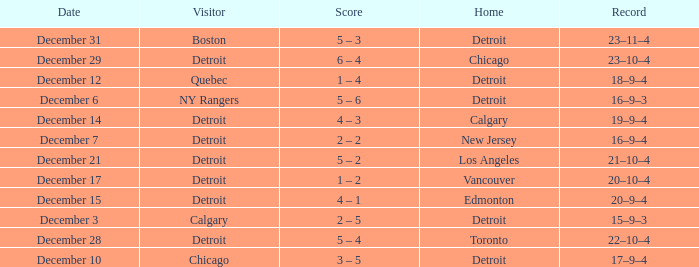Can you identify the person visiting on the 31st of december? Boston. Give me the full table as a dictionary. {'header': ['Date', 'Visitor', 'Score', 'Home', 'Record'], 'rows': [['December 31', 'Boston', '5 – 3', 'Detroit', '23–11–4'], ['December 29', 'Detroit', '6 – 4', 'Chicago', '23–10–4'], ['December 12', 'Quebec', '1 – 4', 'Detroit', '18–9–4'], ['December 6', 'NY Rangers', '5 – 6', 'Detroit', '16–9–3'], ['December 14', 'Detroit', '4 – 3', 'Calgary', '19–9–4'], ['December 7', 'Detroit', '2 – 2', 'New Jersey', '16–9–4'], ['December 21', 'Detroit', '5 – 2', 'Los Angeles', '21–10–4'], ['December 17', 'Detroit', '1 – 2', 'Vancouver', '20–10–4'], ['December 15', 'Detroit', '4 – 1', 'Edmonton', '20–9–4'], ['December 3', 'Calgary', '2 – 5', 'Detroit', '15–9–3'], ['December 28', 'Detroit', '5 – 4', 'Toronto', '22–10–4'], ['December 10', 'Chicago', '3 – 5', 'Detroit', '17–9–4']]} 